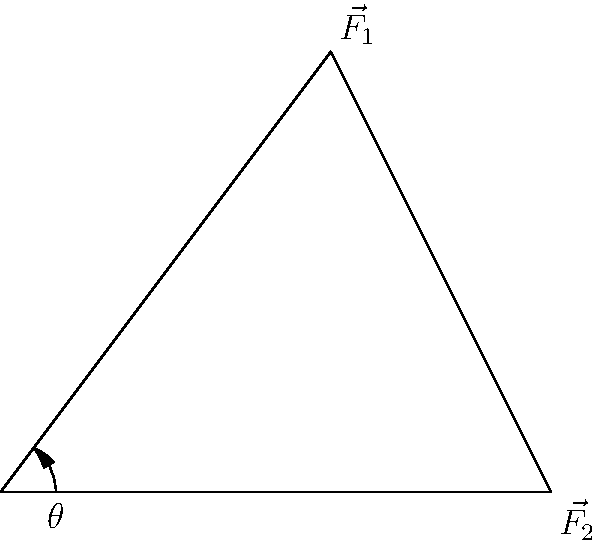During a defensive tackle, you apply two forces on an opponent: $\vec{F_1}$ with magnitude 50 N at an angle of 53° above the horizontal, and $\vec{F_2}$ with magnitude 40 N horizontally. What is the magnitude of the resultant force vector? Let's approach this step-by-step:

1) First, we need to break down $\vec{F_1}$ into its horizontal and vertical components:
   $F_{1x} = 50 \cos(53°) = 30.15$ N
   $F_{1y} = 50 \sin(53°) = 39.98$ N

2) $\vec{F_2}$ is already horizontal, so we don't need to break it down:
   $F_{2x} = 40$ N
   $F_{2y} = 0$ N

3) Now, we can sum the x and y components separately:
   $F_x = F_{1x} + F_{2x} = 30.15 + 40 = 70.15$ N
   $F_y = F_{1y} + F_{2y} = 39.98 + 0 = 39.98$ N

4) The resultant force vector $\vec{R}$ has these x and y components. To find its magnitude, we use the Pythagorean theorem:

   $|\vec{R}| = \sqrt{F_x^2 + F_y^2} = \sqrt{70.15^2 + 39.98^2} = \sqrt{4921.02 + 1598.40} = \sqrt{6519.42} = 80.74$ N

Therefore, the magnitude of the resultant force vector is approximately 80.74 N.
Answer: 80.74 N 